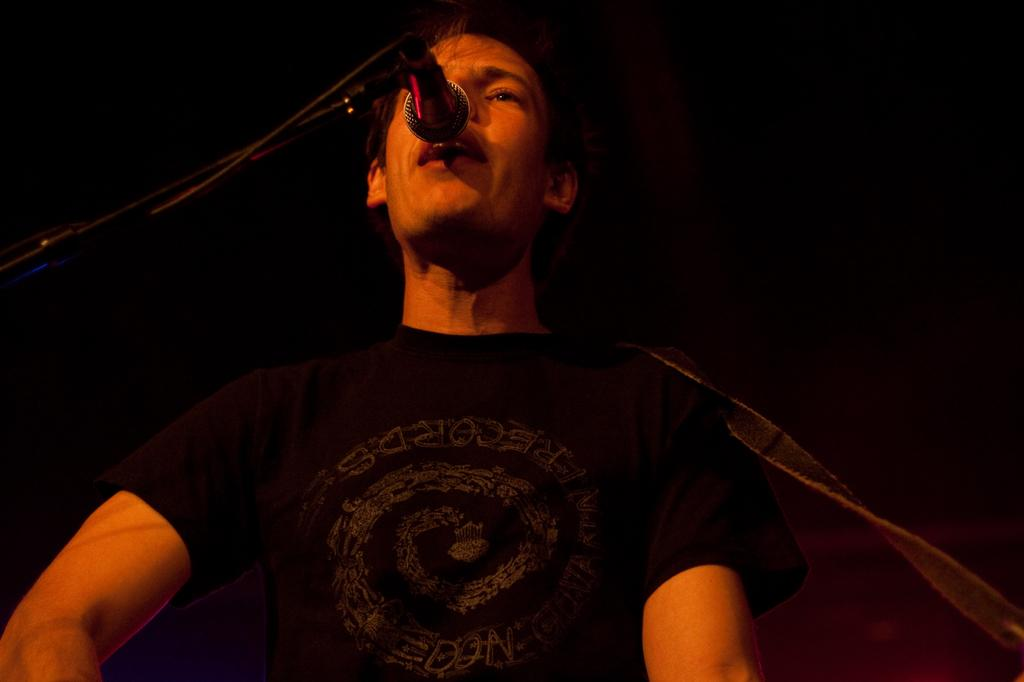What is happening in the image? There is a person in the image who is singing a song. What object is in front of the person? There is a microphone (mike) in front of the person. What type of wound can be seen on the person's hand in the image? There is no wound visible on the person's hand in the image. What kind of offer is the person making to the audience in the image? The image does not show the person making any offer to the audience; they are simply singing with a microphone in front of them. 